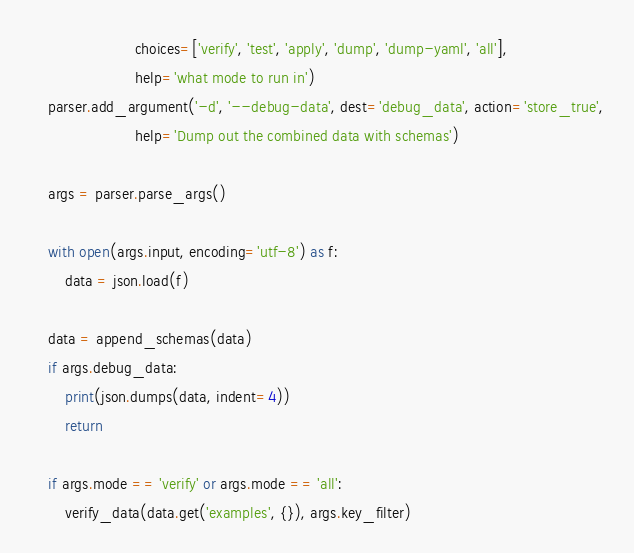Convert code to text. <code><loc_0><loc_0><loc_500><loc_500><_Python_>                        choices=['verify', 'test', 'apply', 'dump', 'dump-yaml', 'all'],
                        help='what mode to run in')
    parser.add_argument('-d', '--debug-data', dest='debug_data', action='store_true',
                        help='Dump out the combined data with schemas')

    args = parser.parse_args()

    with open(args.input, encoding='utf-8') as f:
        data = json.load(f)

    data = append_schemas(data)
    if args.debug_data:
        print(json.dumps(data, indent=4))
        return

    if args.mode == 'verify' or args.mode == 'all':
        verify_data(data.get('examples', {}), args.key_filter)</code> 